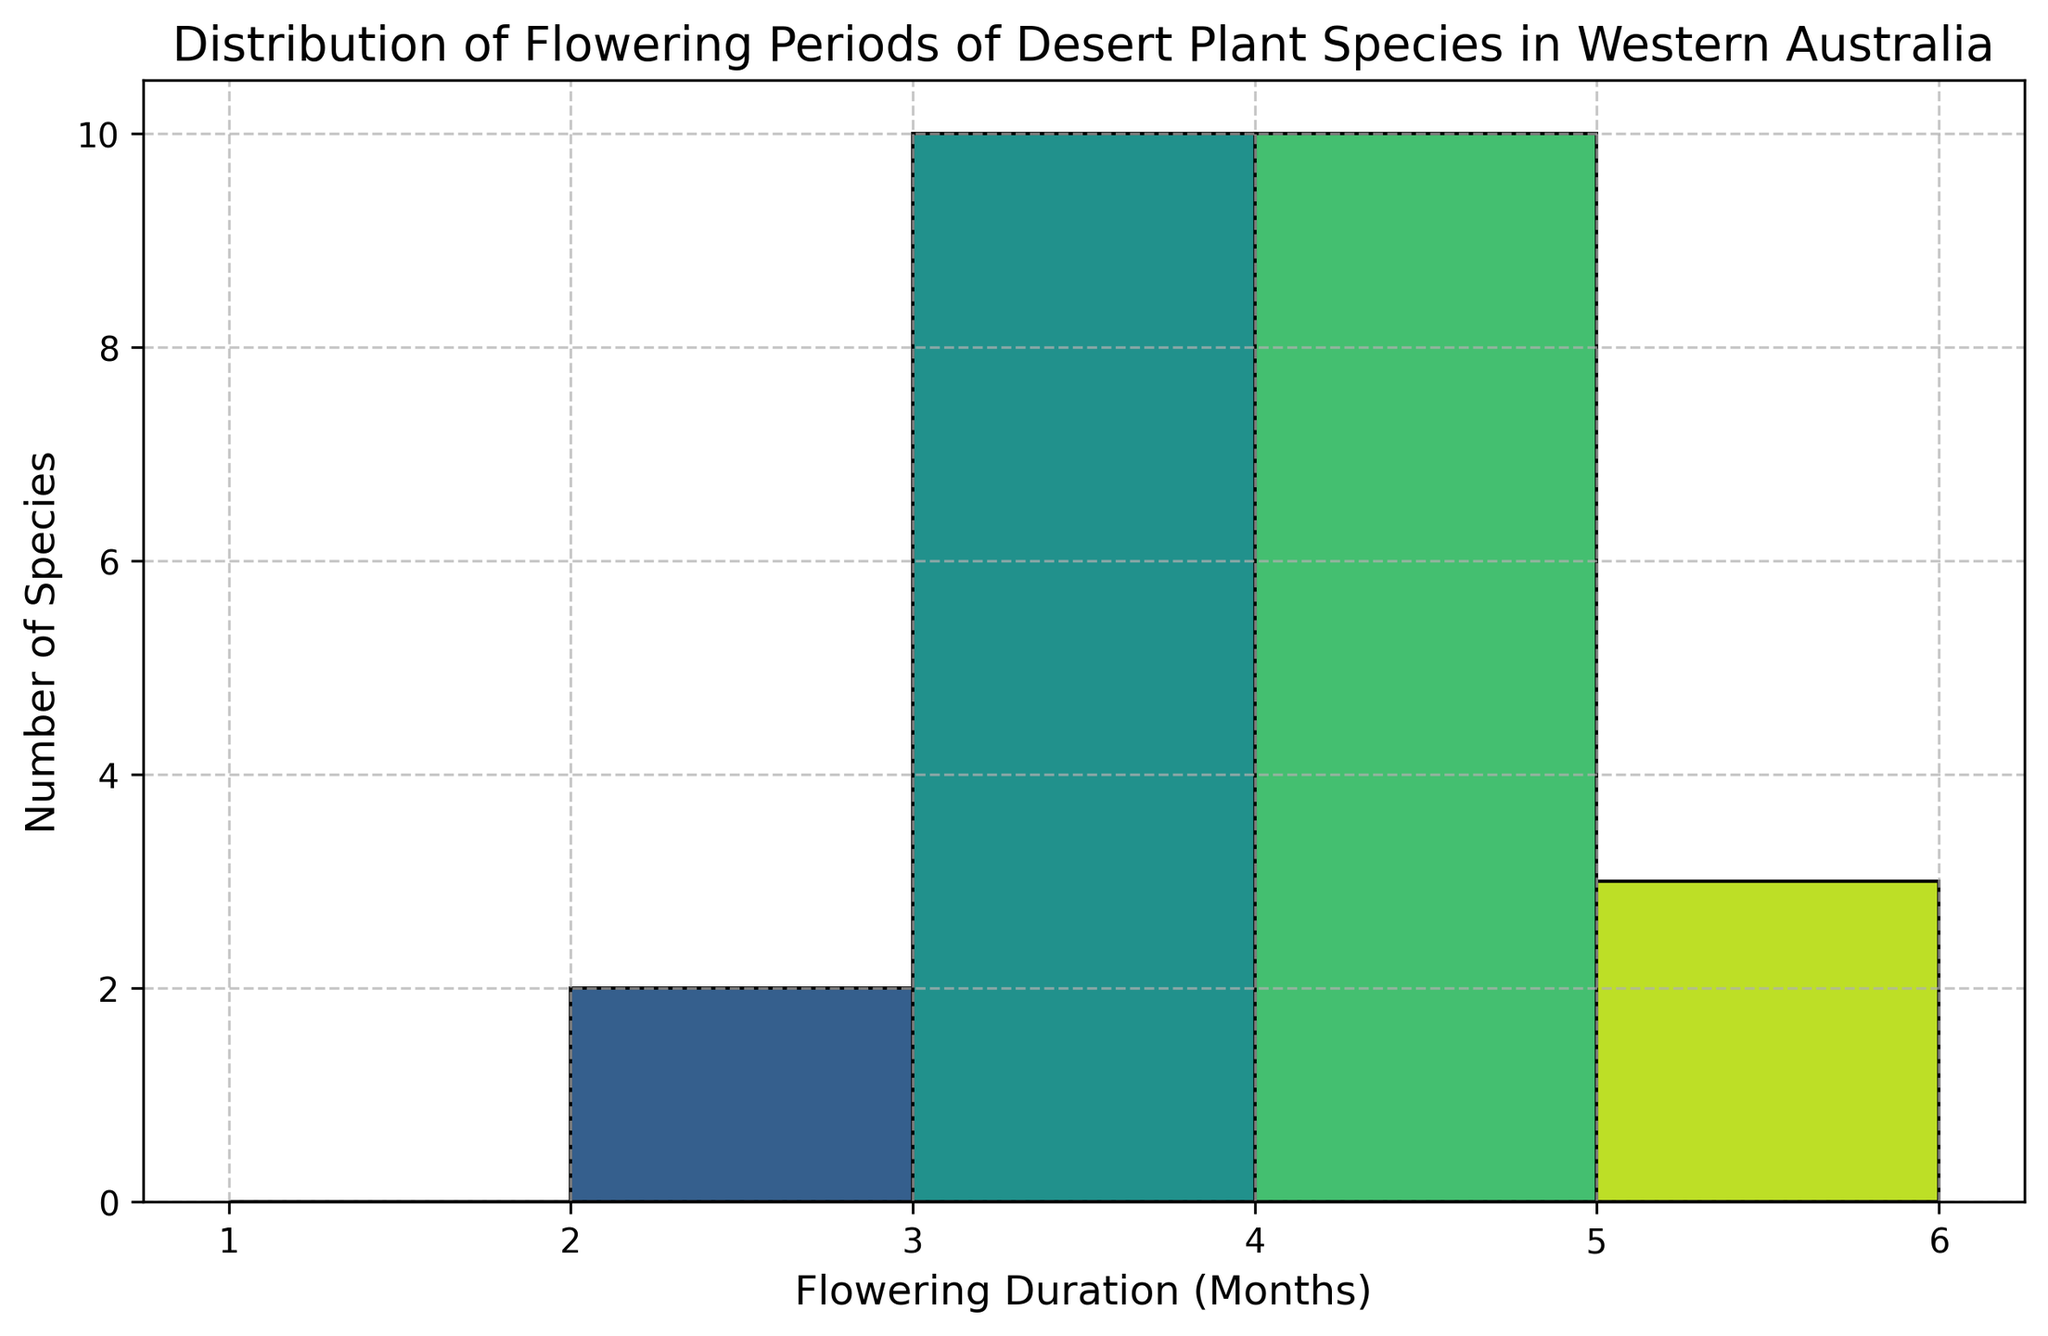How many species have a flowering duration of 3 months? First, identify the bar corresponding to the 3-month flowering duration on the x-axis and then observe the height of the bar. The count of species is equal to the height of the bar.
Answer: 5 Which flowering duration has the maximum number of species? Examine each bar in the histogram and identify the one that reaches the highest point on the y-axis. The x-axis value corresponding to this bar represents the flowering duration with the maximum number of species.
Answer: 2 months How many species flower for less than 4 months? Count the heights of all bars that correspond to flowering durations of 1, 2, and 3 months on the x-axis. Sum these values.
Answer: 16 Are there more species that flower for exactly 5 months or those that flower for exactly 6 months? Compare the heights of the bars at 5 months and 6 months on the x-axis. The one with the higher bar has more species.
Answer: 5 months What is the least common flowering duration? Identify the bar with the smallest height on the y-axis. The x-axis value corresponding to this bar represents the least common flowering duration.
Answer: 7 months How many species flower for more than 5 months? Count the heights of all bars that correspond to flowering durations of 6, 7, and 8 months on the x-axis. Sum these values.
Answer: 5 By how much does the number of species that flower for 2 months exceed those that flower for 1 month? Identify the heights of the bars at 2 and 1 months on the x-axis. Subtract the height of the 1-month bar from the height of the 2-month bar.
Answer: 4 What is the total number of species represented in the histogram? Sum the heights of all the bars in the histogram to get the total number of species.
Answer: 24 Which duration(s) have the same number of species flowering, and what is that number? Look for bars with the same height on the y-axis and record both the duration on the x-axis and the height of these bars.
Answer: 3 months and 4 months both have 5 species each 